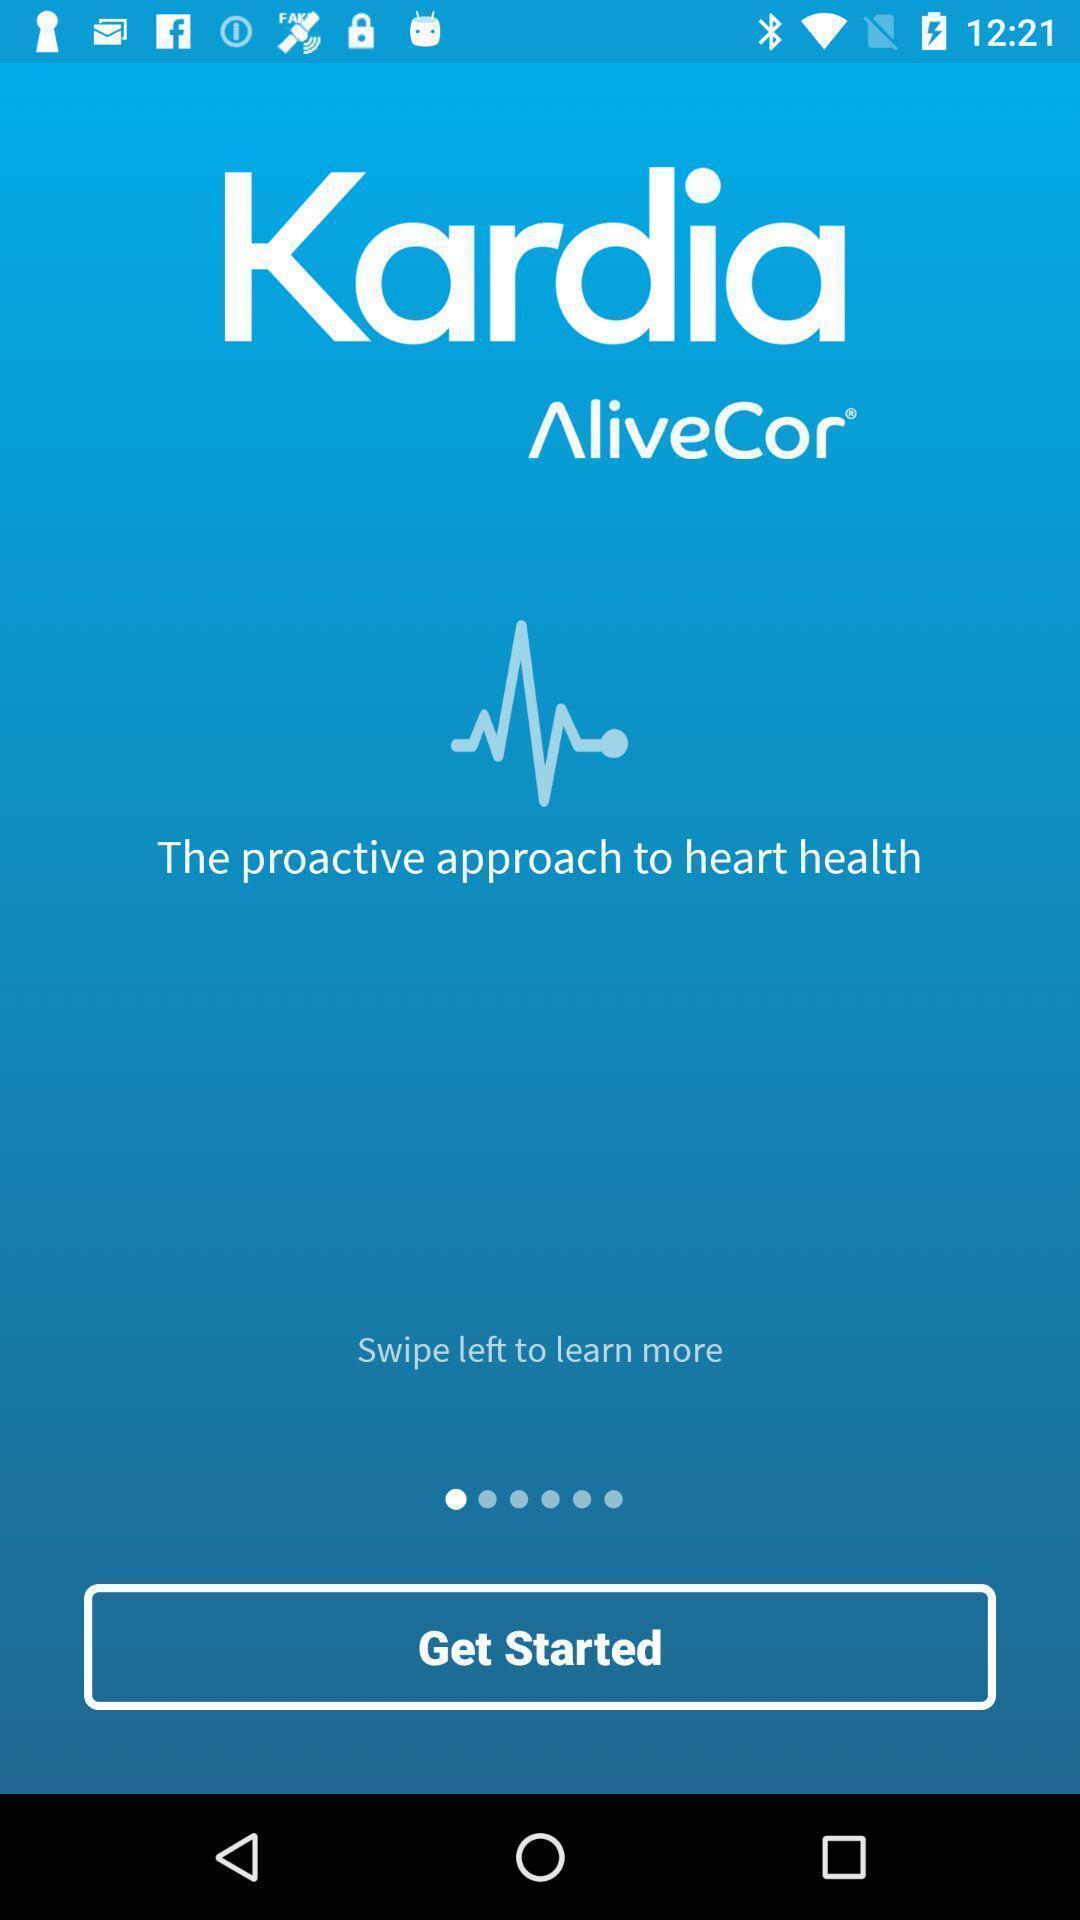Please provide a description for this image. Welcome page. 